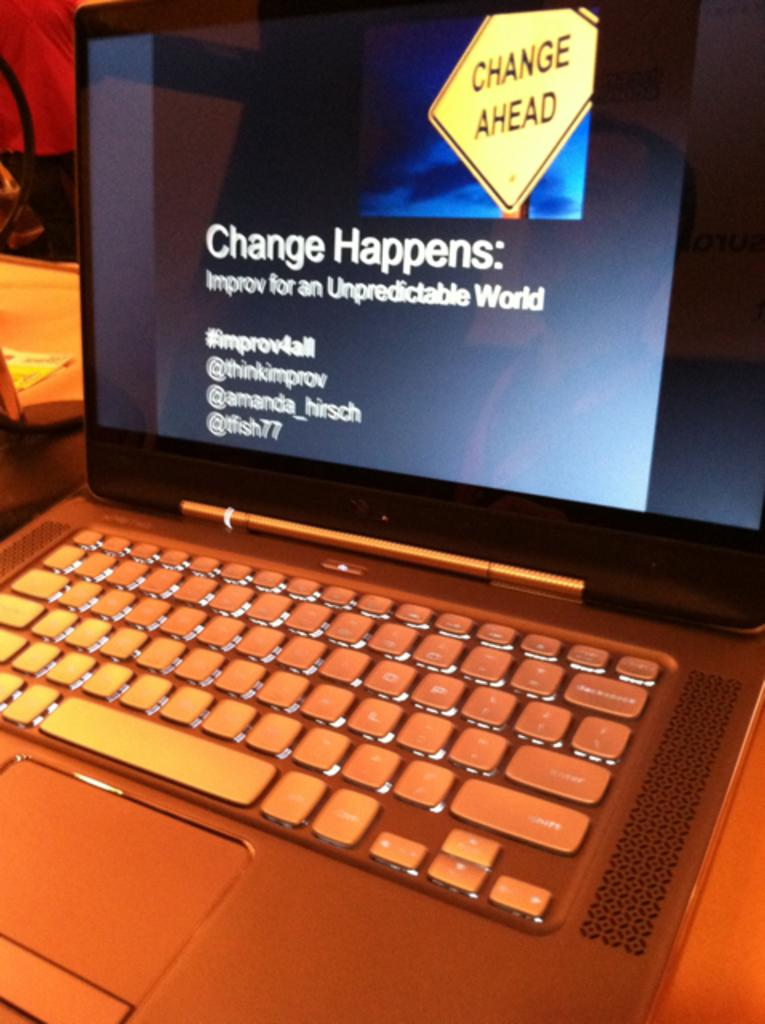<image>
Render a clear and concise summary of the photo. The lap top is open with a CHANGE AHEAD yellow sign and  Change Happens: Improv for an Unpredictable World #improv4all @thinkimprov @amanda_hirsch @tfish77 